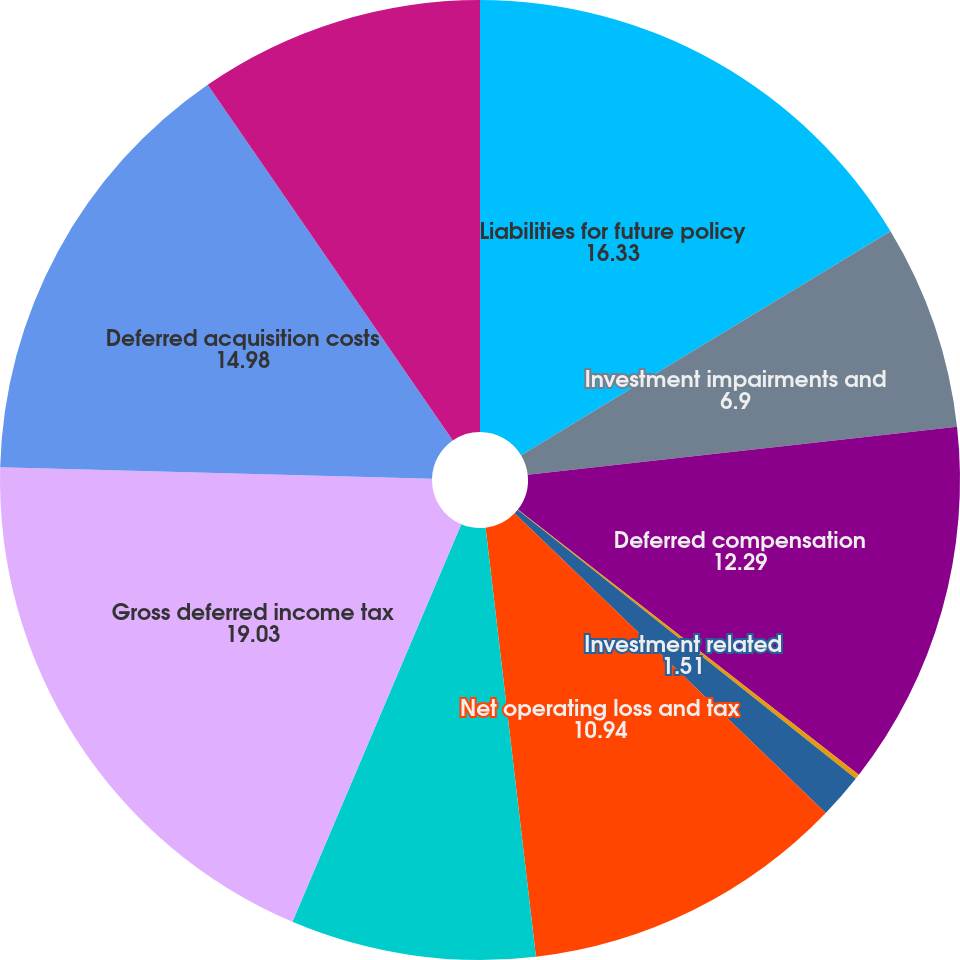Convert chart. <chart><loc_0><loc_0><loc_500><loc_500><pie_chart><fcel>Liabilities for future policy<fcel>Investment impairments and<fcel>Deferred compensation<fcel>Accrued liabilities<fcel>Investment related<fcel>Net operating loss and tax<fcel>Other<fcel>Gross deferred income tax<fcel>Deferred acquisition costs<fcel>Deferred sales inducement<nl><fcel>16.33%<fcel>6.9%<fcel>12.29%<fcel>0.17%<fcel>1.51%<fcel>10.94%<fcel>8.25%<fcel>19.03%<fcel>14.98%<fcel>9.6%<nl></chart> 